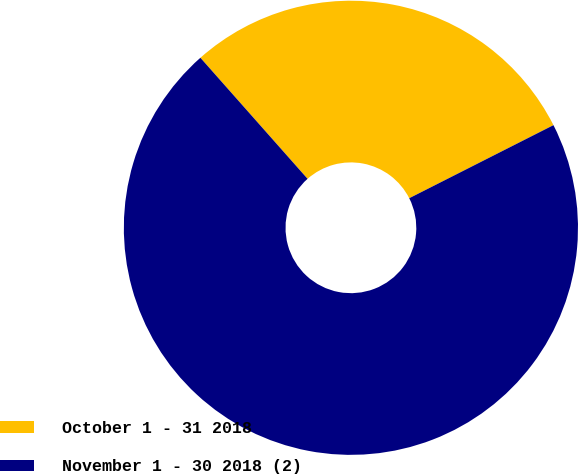Convert chart. <chart><loc_0><loc_0><loc_500><loc_500><pie_chart><fcel>October 1 - 31 2018<fcel>November 1 - 30 2018 (2)<nl><fcel>29.07%<fcel>70.93%<nl></chart> 